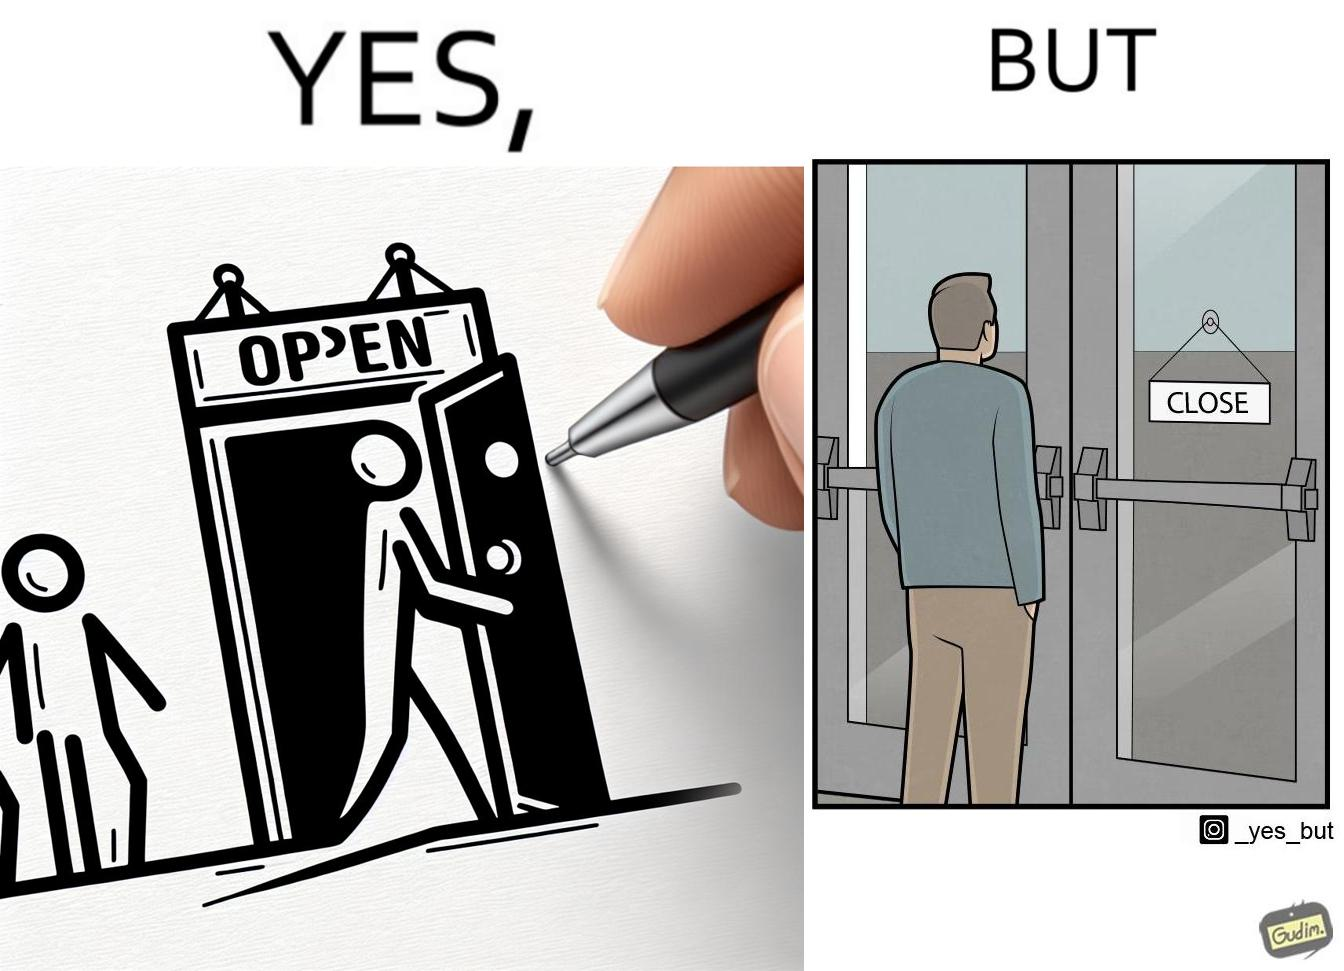Compare the left and right sides of this image. In the left part of the image: a person opening a door with the sign 'OPEN' In the right part of the image: a person standing near a door with the sign 'CLOSE' 